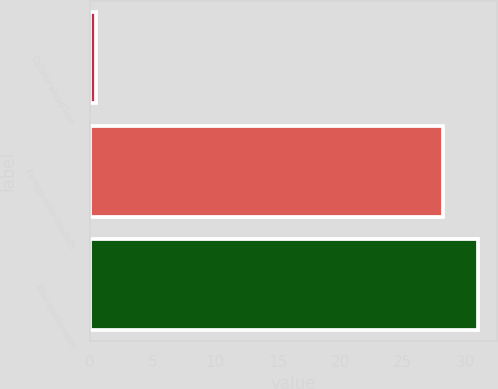<chart> <loc_0><loc_0><loc_500><loc_500><bar_chart><fcel>Collateralized loan<fcel>Foreign time deposits<fcel>Total investments<nl><fcel>0.5<fcel>28.2<fcel>31.02<nl></chart> 